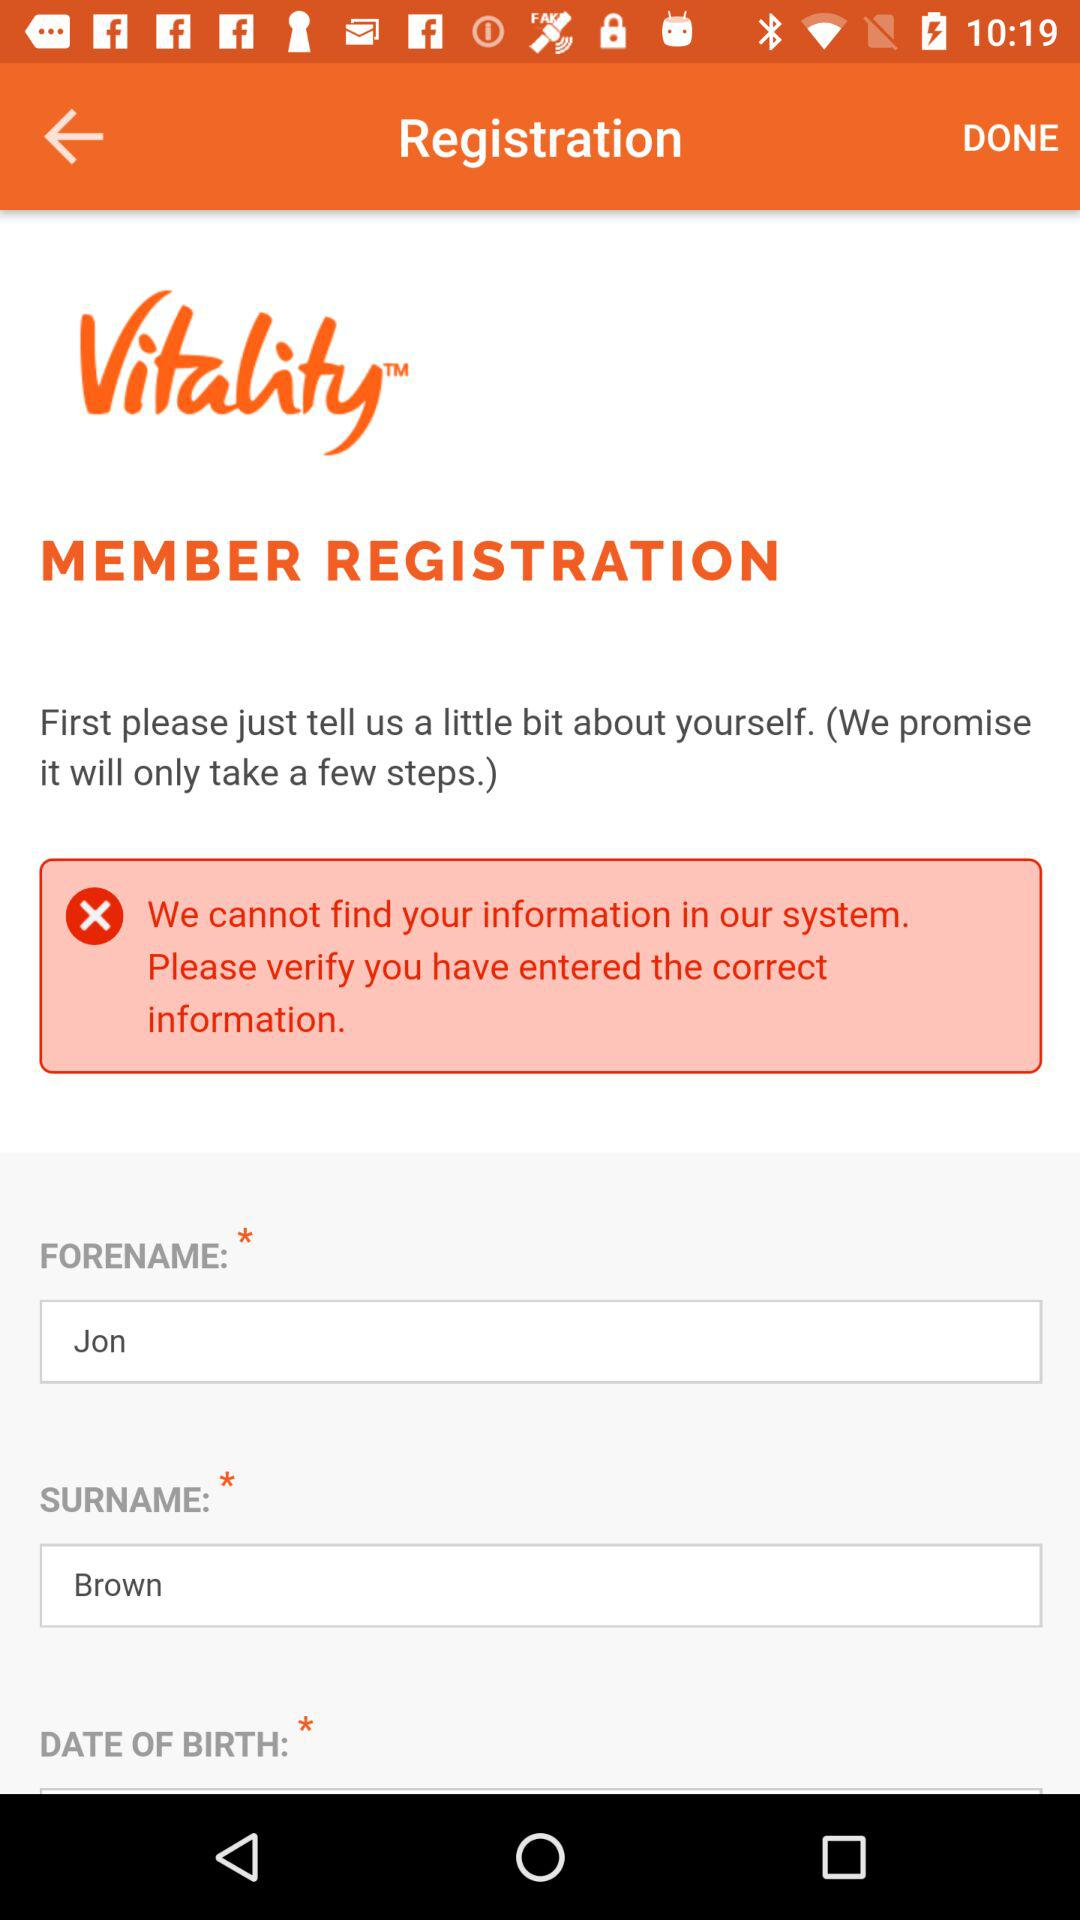What is the forename? The forename is Jon. 